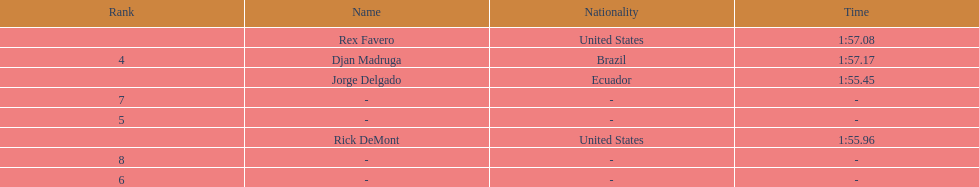Who ended with the top duration? Jorge Delgado. 